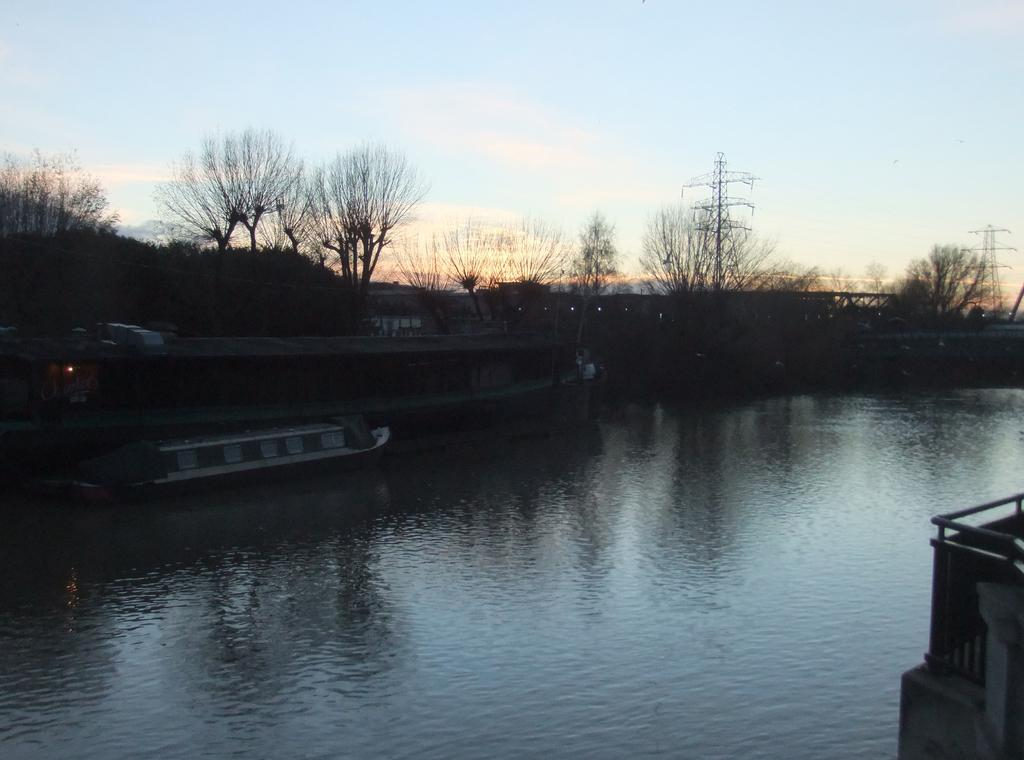What type of structure can be seen in the image? There is a wall in the image. What natural element is visible in the image? Water is visible in the image. What is floating on the water? A boat is floating on the water. What type of vegetation is present in the image? There are trees in the image. What tall structures can be seen in the image? There are towers in the image. What is visible in the background of the image? The sky is visible in the background of the image. Reasoning: Let' Let's think step by step in order to produce the conversation. We start by identifying the main structures and elements in the image based on the provided facts. We then formulate questions that focus on the location and characteristics of these subjects and objects, ensuring that each question can be answered definitively with the information given. We avoid yes/no questions and ensure that the language is simple and clear. Absurd Question/Answer: Can you tell me how many books are floating on the water in the image? A: There are no books present in the image; it features a boat floating on the water. Is there a boundary visible in the image that separates the water from the sky? There is no boundary visible in the image that separates the water from the sky; the water and sky are seamlessly connected. Can you tell me how many people are swimming in the water in the image? There are no people swimming in the water in the image; it features a boat floating on the water. 